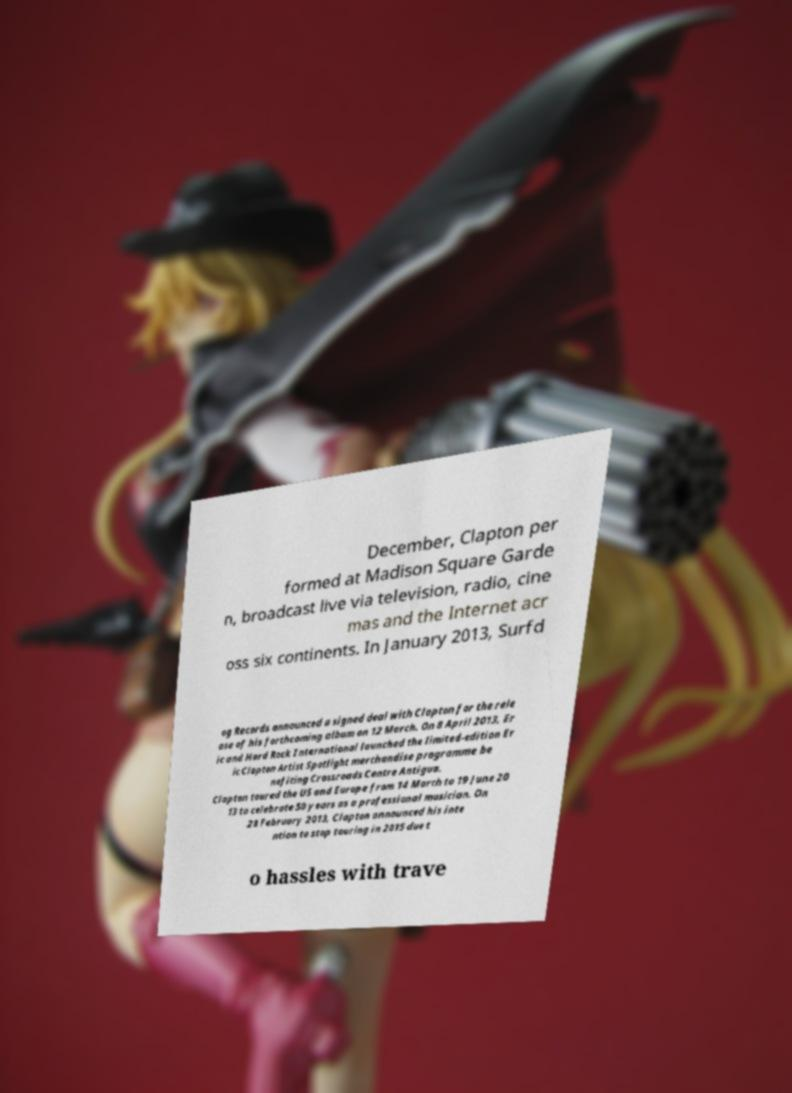I need the written content from this picture converted into text. Can you do that? December, Clapton per formed at Madison Square Garde n, broadcast live via television, radio, cine mas and the Internet acr oss six continents. In January 2013, Surfd og Records announced a signed deal with Clapton for the rele ase of his forthcoming album on 12 March. On 8 April 2013, Er ic and Hard Rock International launched the limited-edition Er ic Clapton Artist Spotlight merchandise programme be nefiting Crossroads Centre Antigua. Clapton toured the US and Europe from 14 March to 19 June 20 13 to celebrate 50 years as a professional musician. On 28 February 2013, Clapton announced his inte ntion to stop touring in 2015 due t o hassles with trave 